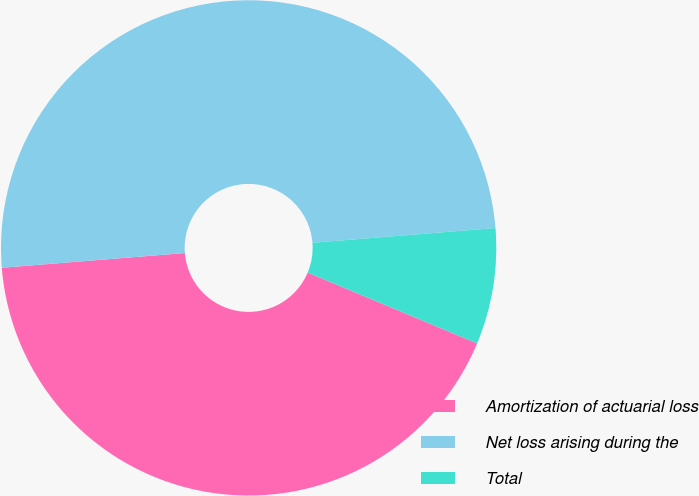Convert chart to OTSL. <chart><loc_0><loc_0><loc_500><loc_500><pie_chart><fcel>Amortization of actuarial loss<fcel>Net loss arising during the<fcel>Total<nl><fcel>42.42%<fcel>50.0%<fcel>7.58%<nl></chart> 